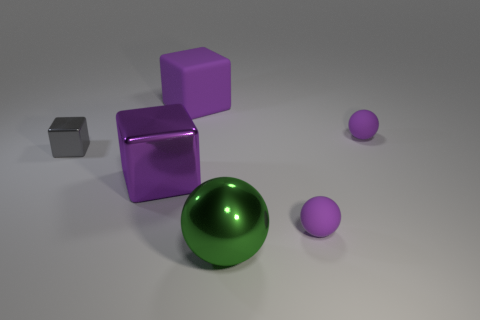Add 3 tiny spheres. How many objects exist? 9 Subtract all shiny objects. Subtract all small rubber things. How many objects are left? 1 Add 4 purple metallic blocks. How many purple metallic blocks are left? 5 Add 1 big purple balls. How many big purple balls exist? 1 Subtract 0 red blocks. How many objects are left? 6 